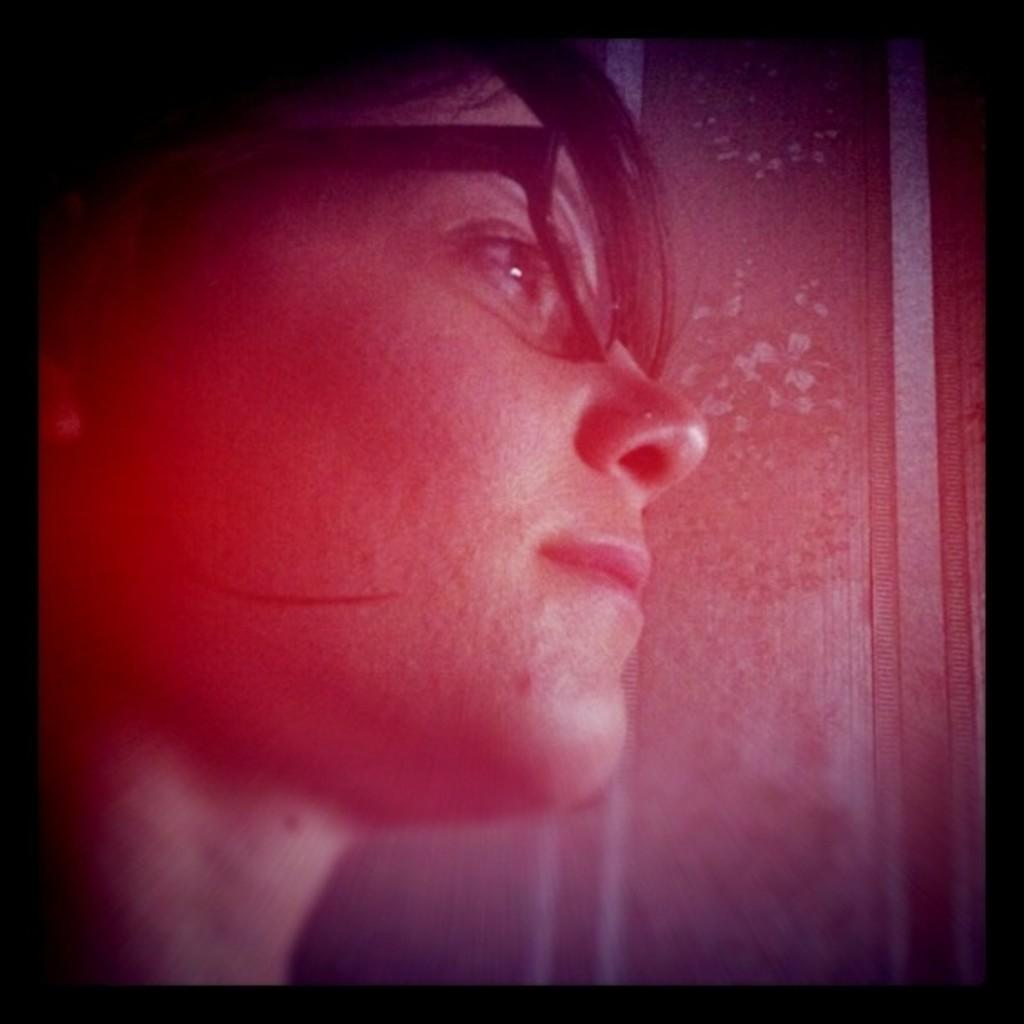What is the main subject of the image? There is a person in the image. Can you describe the person's appearance? The person is wearing spectacles. What can be observed about the background of the image? The background of the image is blurry. How many balls are visible in the image? There are no balls present in the image. What type of winter clothing is the person wearing in the image? The image does not show the person wearing any winter clothing, as it only shows the person wearing spectacles. 